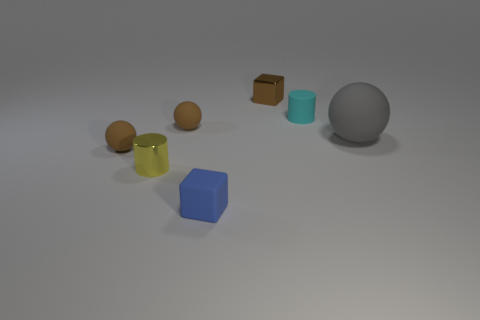Is the number of tiny spheres that are on the right side of the tiny blue rubber object the same as the number of tiny blue cylinders?
Give a very brief answer. Yes. Is the cyan cylinder the same size as the brown metal thing?
Keep it short and to the point. Yes. What number of shiny things are blue things or cyan balls?
Your answer should be very brief. 0. There is a brown block that is the same size as the yellow shiny object; what is its material?
Your response must be concise. Metal. How many other things are the same material as the large gray sphere?
Offer a very short reply. 4. Are there fewer small yellow shiny cylinders that are in front of the blue rubber cube than tiny blue matte things?
Make the answer very short. Yes. Does the small yellow shiny thing have the same shape as the cyan matte thing?
Offer a very short reply. Yes. There is a cylinder behind the small brown matte ball on the left side of the brown matte object that is behind the gray matte object; what size is it?
Offer a very short reply. Small. There is another tiny object that is the same shape as the tiny blue matte object; what is its material?
Provide a short and direct response. Metal. Is there any other thing that has the same size as the gray rubber object?
Provide a succinct answer. No. 